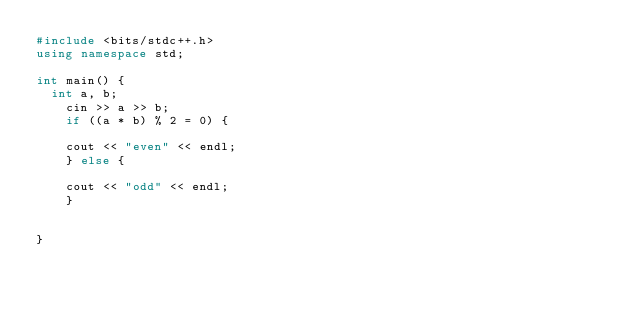Convert code to text. <code><loc_0><loc_0><loc_500><loc_500><_C++_>#include <bits/stdc++.h>
using namespace std;

int main() {
  int a, b;
	cin >> a >> b;
    if ((a * b) % 2 = 0) {
      
	cout << "even" << endl;
    } else {
      
	cout << "odd" << endl;
    }


}</code> 